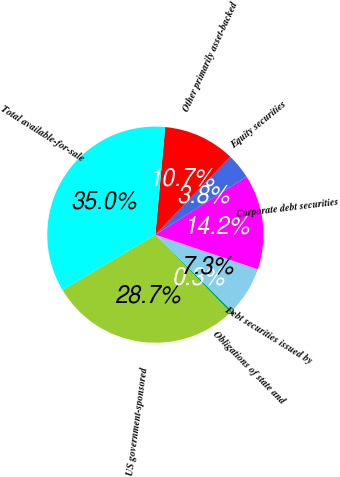<chart> <loc_0><loc_0><loc_500><loc_500><pie_chart><fcel>US government-sponsored<fcel>Obligations of state and<fcel>Debt securities issued by<fcel>Corporate debt securities<fcel>Equity securities<fcel>Other primarily asset-backed<fcel>Total available-for-sale<nl><fcel>28.68%<fcel>0.34%<fcel>7.27%<fcel>14.2%<fcel>3.8%<fcel>10.73%<fcel>34.99%<nl></chart> 